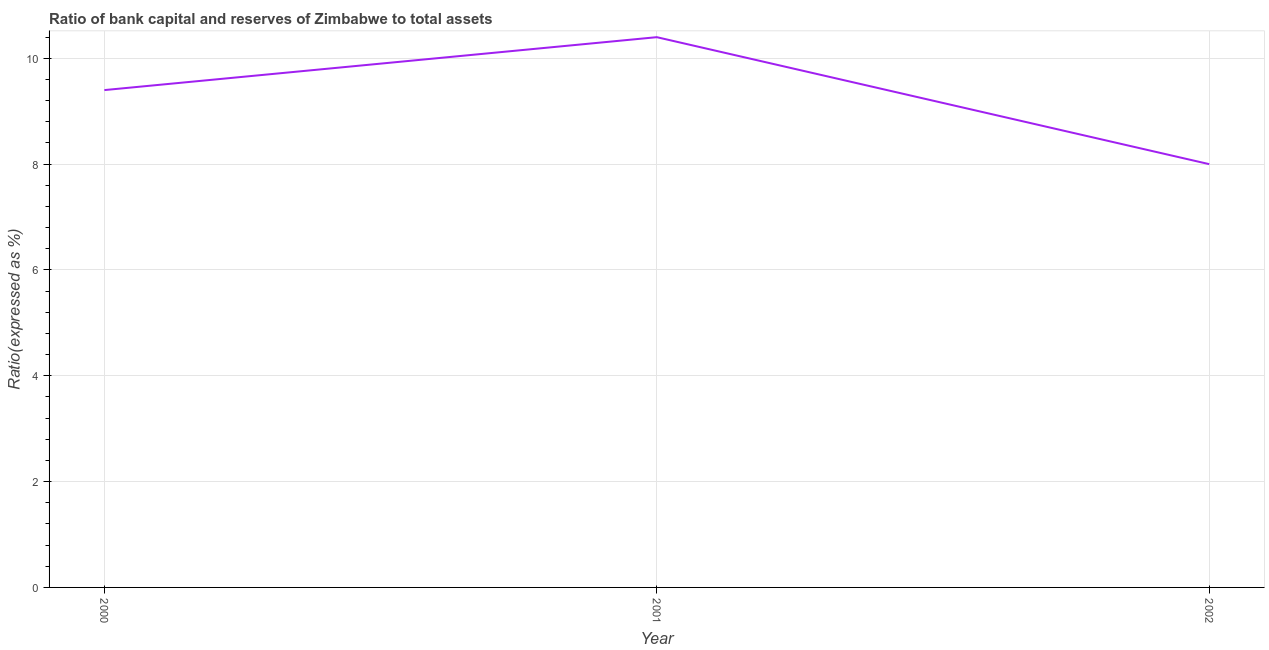What is the bank capital to assets ratio in 2002?
Ensure brevity in your answer.  8. Across all years, what is the maximum bank capital to assets ratio?
Your response must be concise. 10.4. What is the sum of the bank capital to assets ratio?
Your response must be concise. 27.8. What is the difference between the bank capital to assets ratio in 2001 and 2002?
Give a very brief answer. 2.4. What is the average bank capital to assets ratio per year?
Your answer should be compact. 9.27. What is the median bank capital to assets ratio?
Give a very brief answer. 9.4. Do a majority of the years between 2001 and 2000 (inclusive) have bank capital to assets ratio greater than 6.8 %?
Ensure brevity in your answer.  No. What is the ratio of the bank capital to assets ratio in 2000 to that in 2001?
Offer a terse response. 0.9. Is the difference between the bank capital to assets ratio in 2000 and 2002 greater than the difference between any two years?
Make the answer very short. No. What is the difference between the highest and the second highest bank capital to assets ratio?
Offer a very short reply. 1. What is the difference between the highest and the lowest bank capital to assets ratio?
Offer a very short reply. 2.4. How many lines are there?
Your answer should be very brief. 1. Are the values on the major ticks of Y-axis written in scientific E-notation?
Ensure brevity in your answer.  No. What is the title of the graph?
Offer a terse response. Ratio of bank capital and reserves of Zimbabwe to total assets. What is the label or title of the Y-axis?
Make the answer very short. Ratio(expressed as %). What is the Ratio(expressed as %) of 2000?
Offer a terse response. 9.4. What is the Ratio(expressed as %) in 2001?
Your response must be concise. 10.4. What is the Ratio(expressed as %) in 2002?
Your response must be concise. 8. What is the difference between the Ratio(expressed as %) in 2000 and 2001?
Keep it short and to the point. -1. What is the difference between the Ratio(expressed as %) in 2000 and 2002?
Make the answer very short. 1.4. What is the ratio of the Ratio(expressed as %) in 2000 to that in 2001?
Offer a terse response. 0.9. What is the ratio of the Ratio(expressed as %) in 2000 to that in 2002?
Offer a terse response. 1.18. What is the ratio of the Ratio(expressed as %) in 2001 to that in 2002?
Your answer should be compact. 1.3. 